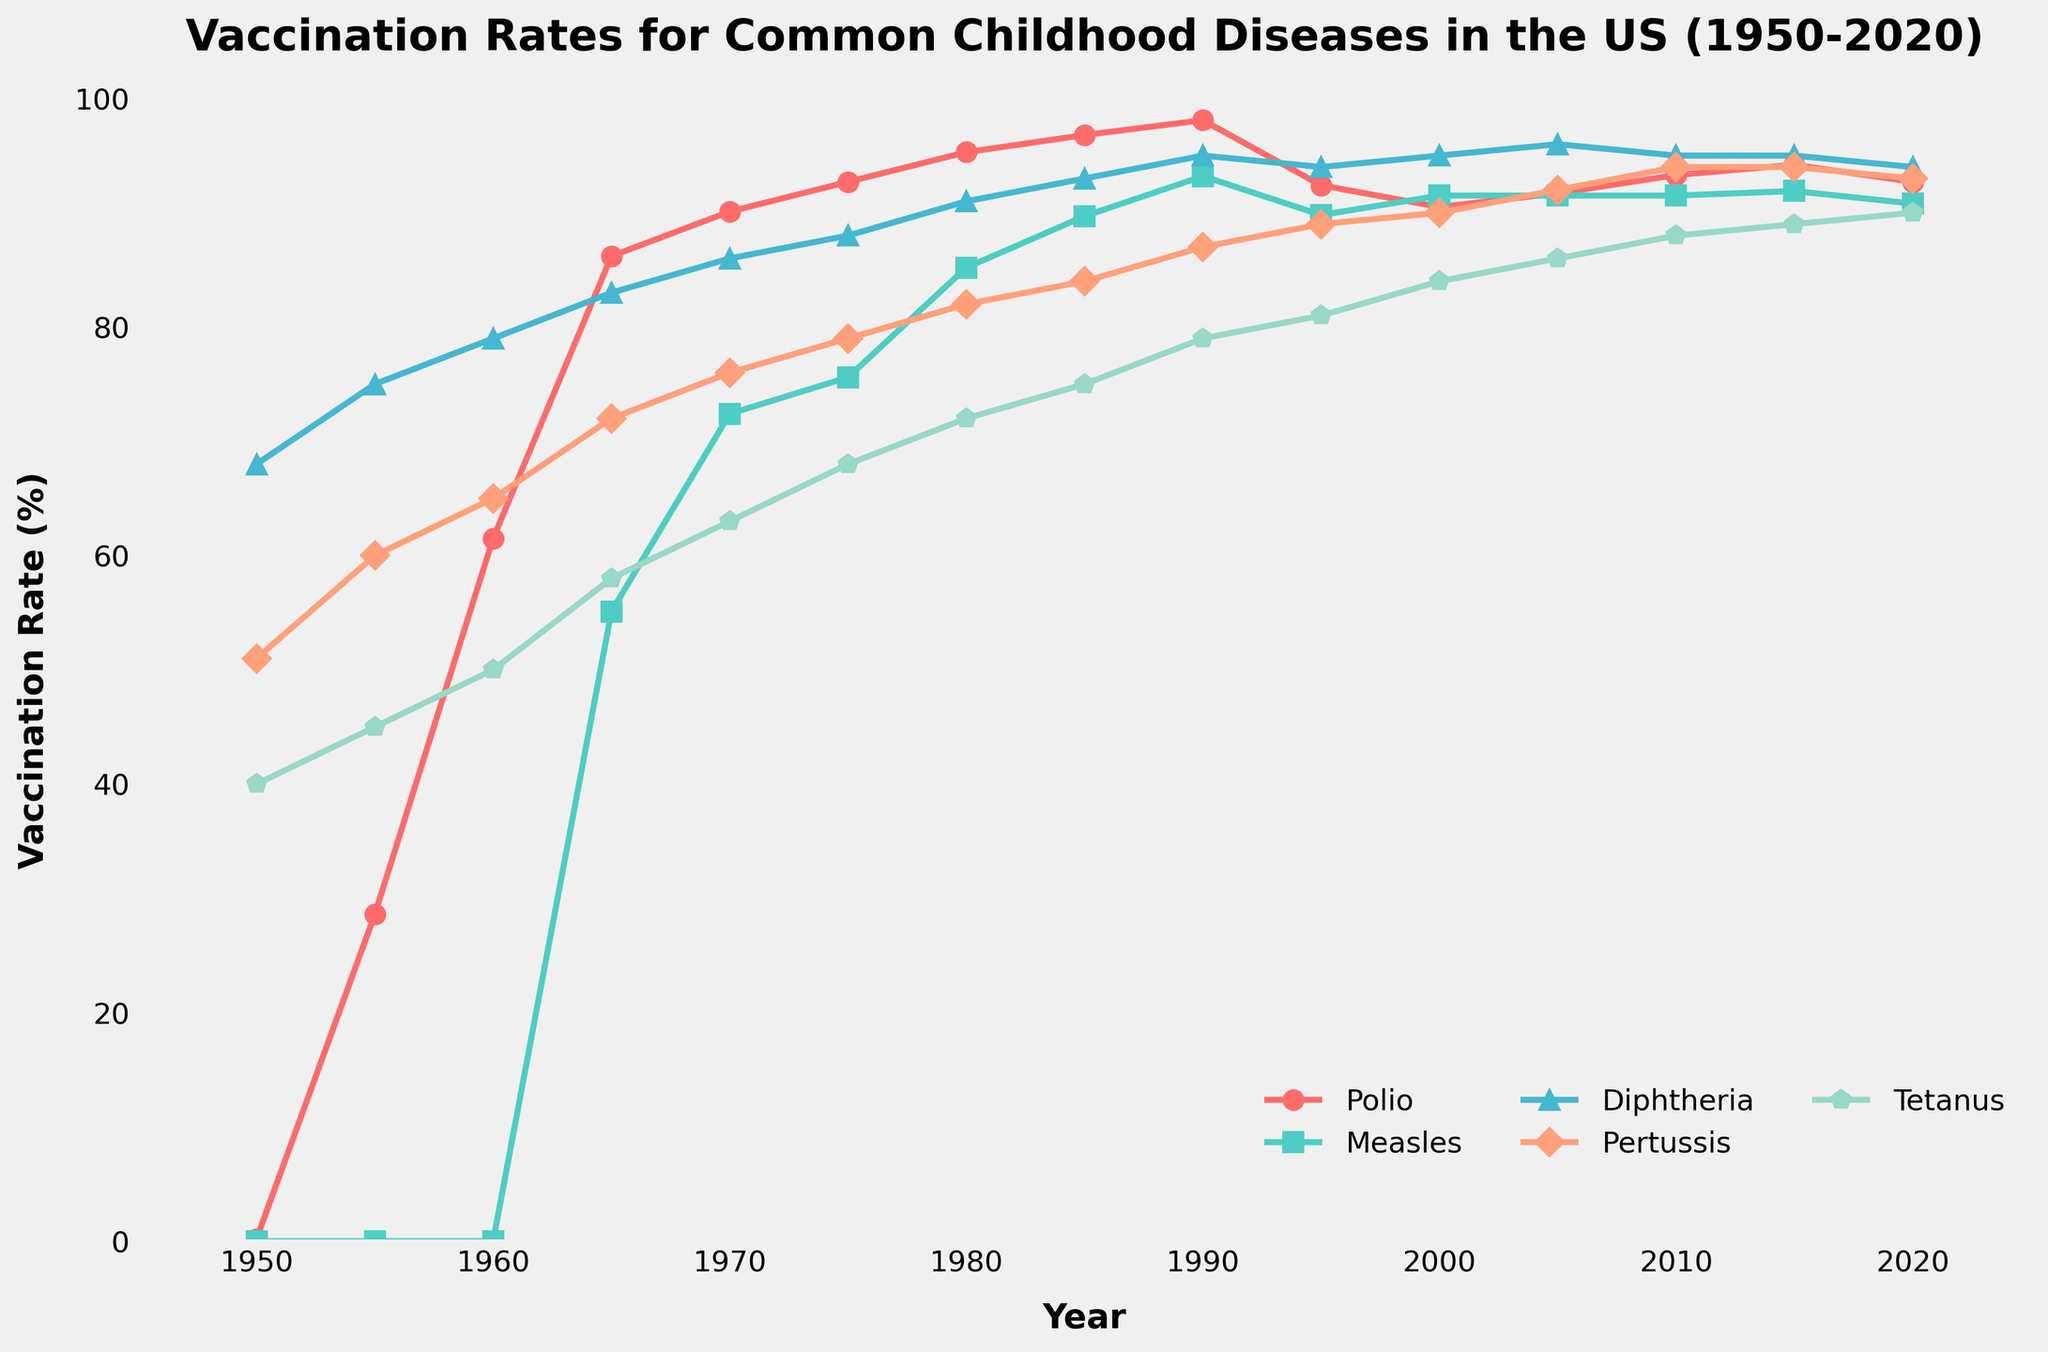What was the vaccination rate for Polio in 1960? To determine the vaccination rate for Polio in 1960, locate the year 1960 on the x-axis and follow the line for Polio (red) vertically up to the corresponding value on the y-axis.
Answer: 61.5% How did the vaccination rates for Measles change between 1965 and 1970? Identify the vaccination rates for Measles in both 1965 and 1970 from the figure. In 1965, the rate is around 55.1%, and in 1970, it is approximately 72.4%. The change is calculated by subtracting the earlier value from the later value: 72.4 - 55.1 = 17.3%.
Answer: Increased by 17.3% Which disease had the lowest vaccination rate in 1950, and what was the percentage? Observe the starting points of each line in 1950. The line that starts with the lowest value represents the disease with the lowest vaccination rate. In this case, Measles had a rate of 0%.
Answer: Measles, 0% Did any disease reach a vaccination rate of 100% at any point between 1950 and 2020? By examining the y-axis values of all the lines throughout the years, it is evident that no line reaches the 100% mark.
Answer: No What is the median vaccination rate for Diphtheria between 1950 and 2020? To find the median, list the vaccination rates for Diphtheria in ascending order: 68, 75, 79, 83, 86, 88, 91, 93, 94, 94, 95, 95, 96. Since there are 13 values, the median is the 7th value: 91%.
Answer: 91% Which disease showed the most significant improvement in vaccination rates between 1950 and 1960? Calculate the change for each disease between 1950 and 1960. Polio: 61.5-0.2=61.3%, Measles: 0-0%=0%, Diphtheria: 79-68=11%, Pertussis: 65-51=14%, Tetanus: 50-40=10%. Polio had the highest increase.
Answer: Polio Compare the trend lines for Pertussis and Tetanus. Which one had a higher rate of increase in vaccination rate from 1980 to 1990? Look at the points for Pertussis and Tetanus in 1980 and 1990, and calculate the increase: Pertussis: 87-82=5%, Tetanus: 79-72=7%. Tetanus had a higher increase.
Answer: Tetanus What can be inferred about the overall trend of vaccination rates for Diphtheria and Pertussis from 1950 to 2020? Both Diphtheria and Pertussis show a generally upward trend, meaning that their vaccination rates have increased over the years, though with some fluctuations around 1995 for Diphtheria.
Answer: Upward trend Is there any year where all diseases had vaccination rates above 80%? Check each year’s data for all diseases; starting from 1980, all five diseases have rates above 80%.
Answer: Yes, from 1980 onwards How does the vaccination rate for Tetanus in 2020 compare to its rate in 1970? Locate the points for Tetanus in 1970 and 2020 and compare them. In 1970, the rate is 63%, and in 2020, it is approximately 90%. Thus, the rate has increased significantly.
Answer: Higher in 2020 